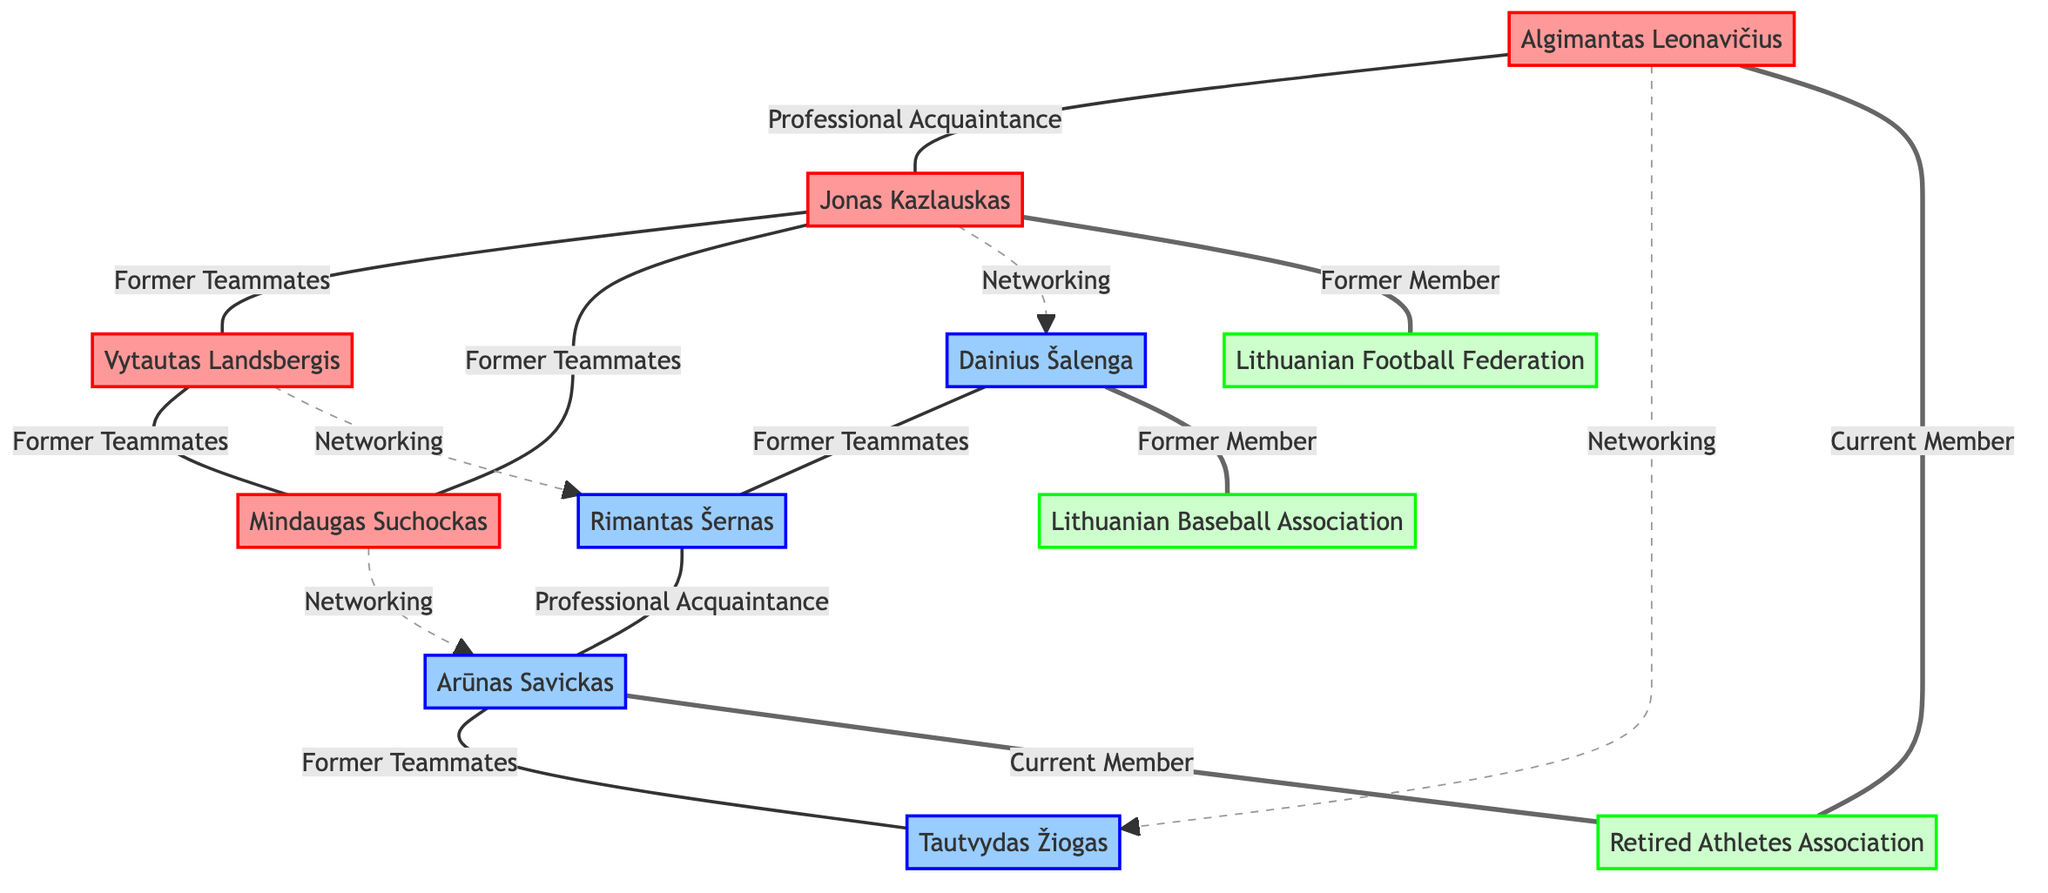What is the total number of nodes in the diagram? The diagram lists a total of 11 nodes, which include 4 football players, 4 baseball players, and 3 organizations.
Answer: 11 Who are the professional acquaintances of Rimantas Šernas? The diagram shows that Rimantas Šernas has a professional acquaintance with Arūnas Savickas. This is indicated by the edge labeled "Professional Acquaintance" connecting these two nodes.
Answer: Arūnas Savickas How many former teammates are there among football players? There are three edges representing former teammates among the football players: Jonas Kazlauskas with Vytautas Landsbergis, Jonas Kazlauskas with Mindaugas Suchockas, and Vytautas Landsbergis with Mindaugas Suchockas. This counts a total of three relationships.
Answer: 3 Which organization is Dainius Šalenga connected to? The diagram indicates that Dainius Šalenga is connected to the Lithuanian Baseball Association as a "Former Member." This is represented by an edge labeled "Former Member" leading from Dainius Šalenga to the Lithuanian Baseball Association.
Answer: Lithuanian Baseball Association How does Algimantas Leonavičius connect to Tautvydas Žiogas? The diagram shows that Algimantas Leonavičius has a networking relationship with Tautvydas Žiogas, indicated by the dashed edge labeled "Networking through Association" between them.
Answer: Networking through Association How many current members are represented in the diagram? There are 2 current members shown in the diagram, which are Algimantas Leonavičius and Arūnas Savickas, both connected to the Retired Athletes Association.
Answer: 2 Who has a networking connection with both Jonas Kazlauskas and Dainius Šalenga? The diagram illustrates that Jonas Kazlauskas has a networking connection with Dainius Šalenga. This is indicated by an edge labeled "Networking through Association" connecting the two nodes.
Answer: Dainius Šalenga Which edge represents a former teammate relationship between football players? The edge between Jonas Kazlauskas and Vytautas Landsbergis is labeled "Former Teammates," indicating a connection based on their past collaboration in football.
Answer: Former Teammates What kind of relationship exists between Mindaugas Suchockas and Arūnas Savickas? The diagram indicates a networking relationship between Mindaugas Suchockas and Arūnas Savickas, which is labeled as "Networking through Association."
Answer: Networking through Association 